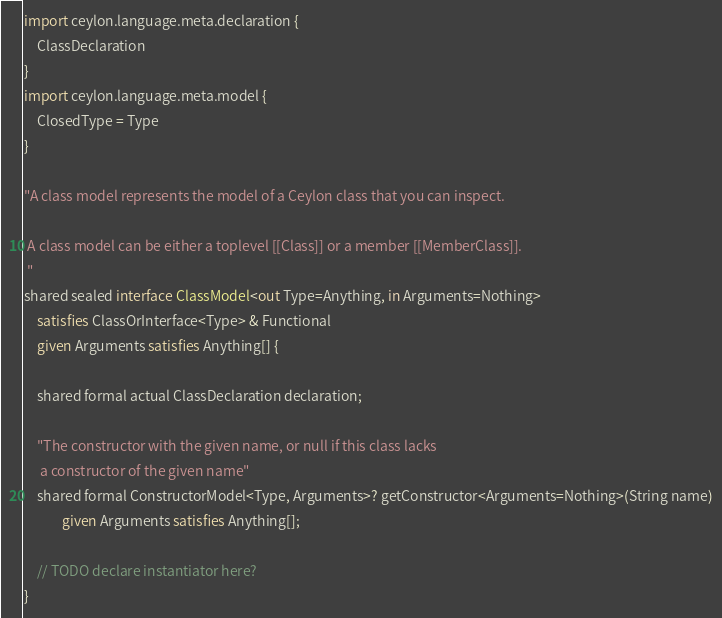Convert code to text. <code><loc_0><loc_0><loc_500><loc_500><_Ceylon_>import ceylon.language.meta.declaration {
    ClassDeclaration
}
import ceylon.language.meta.model {
    ClosedType = Type
}

"A class model represents the model of a Ceylon class that you can inspect.
 
 A class model can be either a toplevel [[Class]] or a member [[MemberClass]].
 "
shared sealed interface ClassModel<out Type=Anything, in Arguments=Nothing>
    satisfies ClassOrInterface<Type> & Functional
    given Arguments satisfies Anything[] {
    
    shared formal actual ClassDeclaration declaration;
    
    "The constructor with the given name, or null if this class lacks 
     a constructor of the given name"
    shared formal ConstructorModel<Type, Arguments>? getConstructor<Arguments=Nothing>(String name)
            given Arguments satisfies Anything[];
    
    // TODO declare instantiator here?
}
</code> 